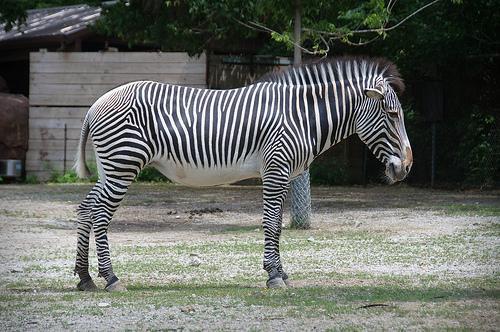How many zebras are there?
Give a very brief answer. 1. 